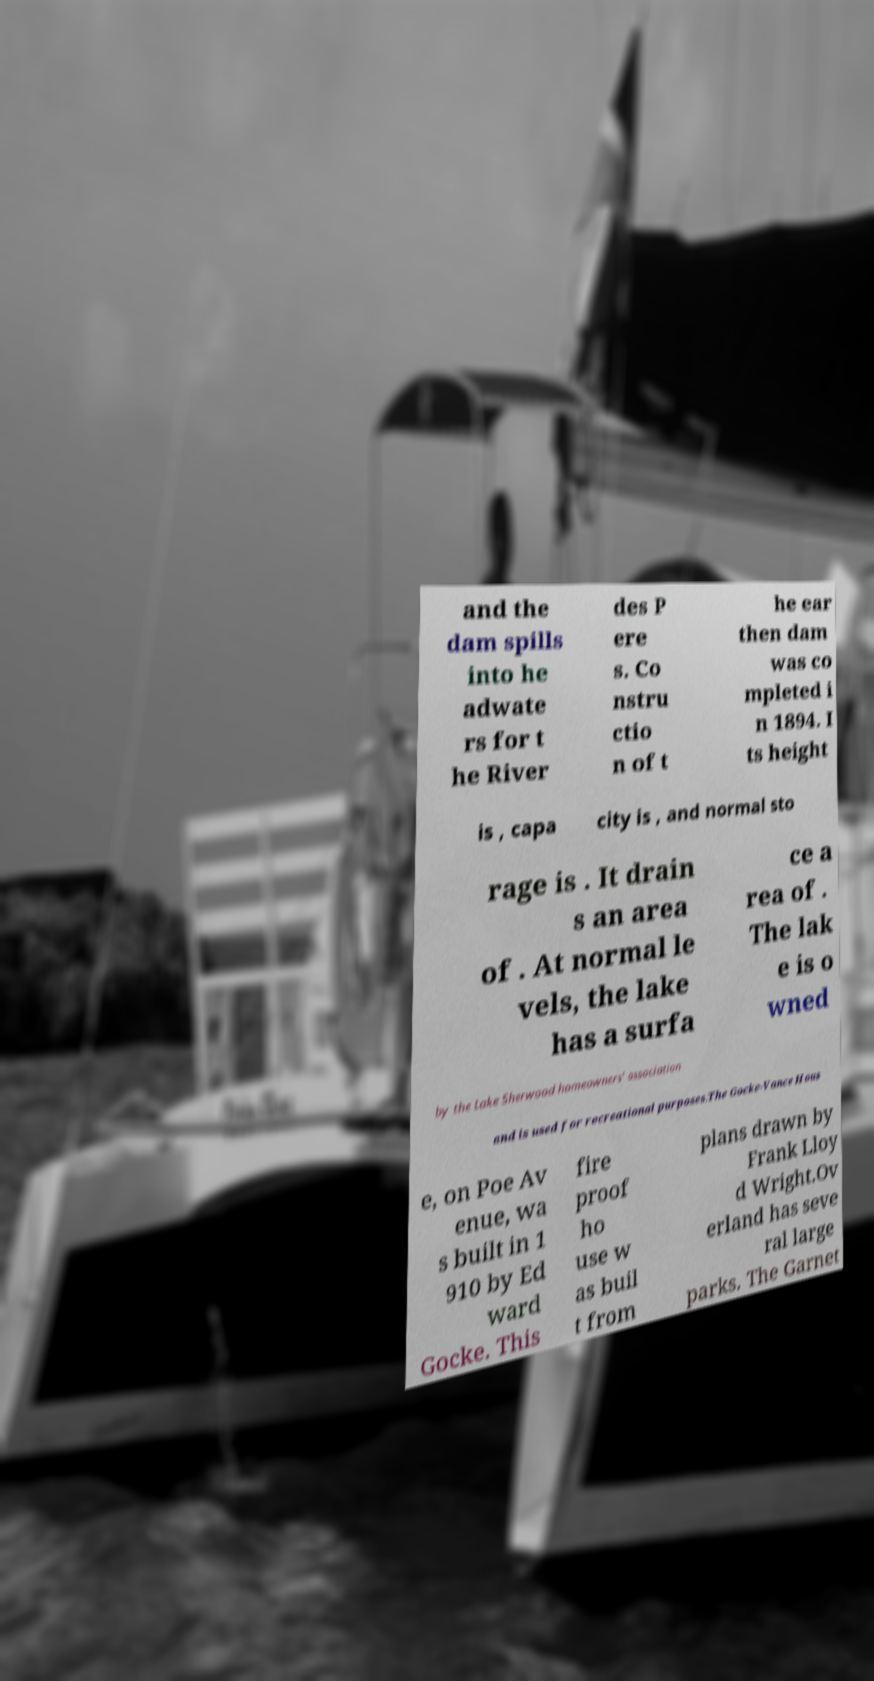For documentation purposes, I need the text within this image transcribed. Could you provide that? and the dam spills into he adwate rs for t he River des P ere s. Co nstru ctio n of t he ear then dam was co mpleted i n 1894. I ts height is , capa city is , and normal sto rage is . It drain s an area of . At normal le vels, the lake has a surfa ce a rea of . The lak e is o wned by the Lake Sherwood homeowners' association and is used for recreational purposes.The Gocke-Vance Hous e, on Poe Av enue, wa s built in 1 910 by Ed ward Gocke. This fire proof ho use w as buil t from plans drawn by Frank Lloy d Wright.Ov erland has seve ral large parks. The Garnet 